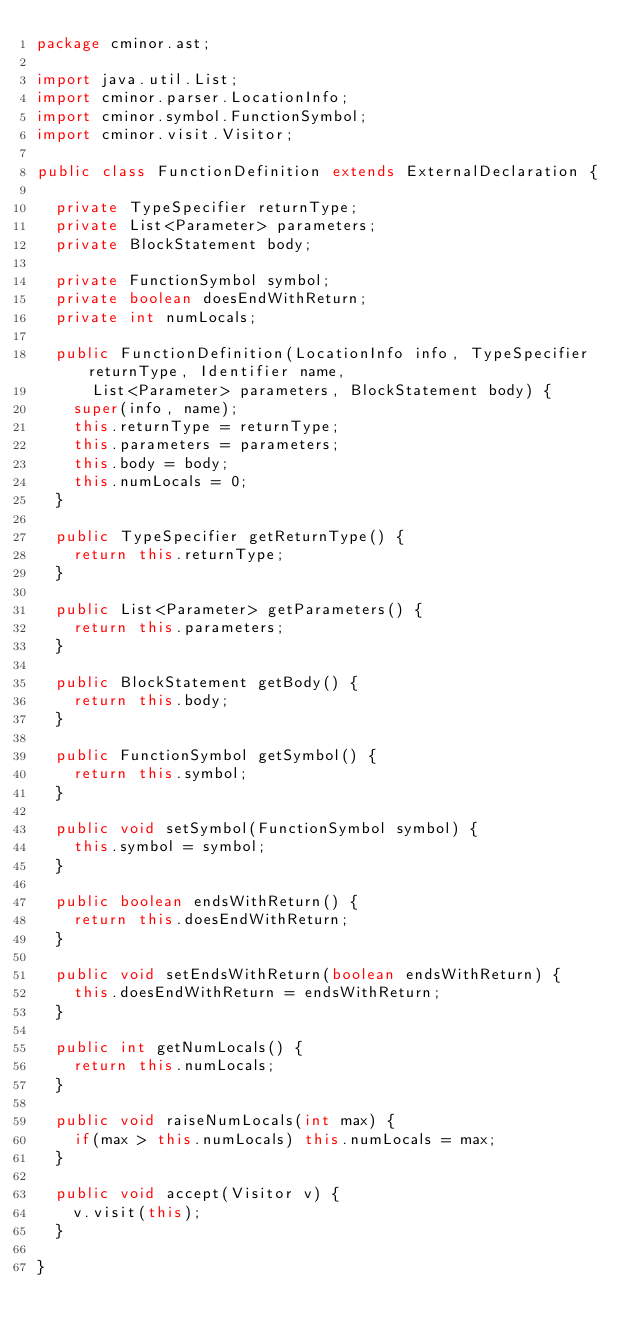<code> <loc_0><loc_0><loc_500><loc_500><_Java_>package cminor.ast;

import java.util.List;
import cminor.parser.LocationInfo;
import cminor.symbol.FunctionSymbol;
import cminor.visit.Visitor;

public class FunctionDefinition extends ExternalDeclaration {

	private TypeSpecifier returnType;
	private List<Parameter> parameters;
	private BlockStatement body;

	private FunctionSymbol symbol;
	private boolean doesEndWithReturn;
	private int numLocals;

	public FunctionDefinition(LocationInfo info, TypeSpecifier returnType, Identifier name,
			List<Parameter> parameters, BlockStatement body) {
		super(info, name);
		this.returnType = returnType;
		this.parameters = parameters;
		this.body = body;
		this.numLocals = 0;
	}

	public TypeSpecifier getReturnType() {
		return this.returnType;
	}

	public List<Parameter> getParameters() {
		return this.parameters;
	}

	public BlockStatement getBody() {
		return this.body;
	}

	public FunctionSymbol getSymbol() {
		return this.symbol;
	}

	public void setSymbol(FunctionSymbol symbol) {
		this.symbol = symbol;
	}

	public boolean endsWithReturn() {
		return this.doesEndWithReturn;
	}

	public void setEndsWithReturn(boolean endsWithReturn) {
		this.doesEndWithReturn = endsWithReturn;
	}

	public int getNumLocals() {
		return this.numLocals;
	}

	public void raiseNumLocals(int max) {
		if(max > this.numLocals) this.numLocals = max;
	}

	public void accept(Visitor v) {
		v.visit(this);
	}

}
</code> 